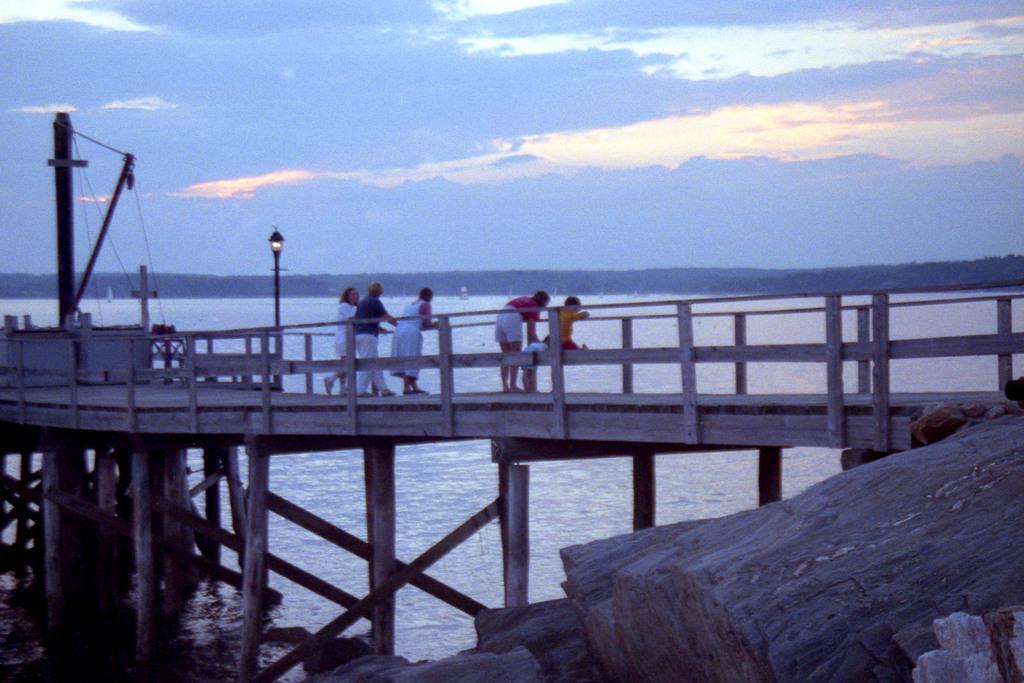How would you summarize this image in a sentence or two? In this image I can see a platform and on it I can see few people are standing. I can also see few poles, wires, a light, water, clouds and the sky in background. 